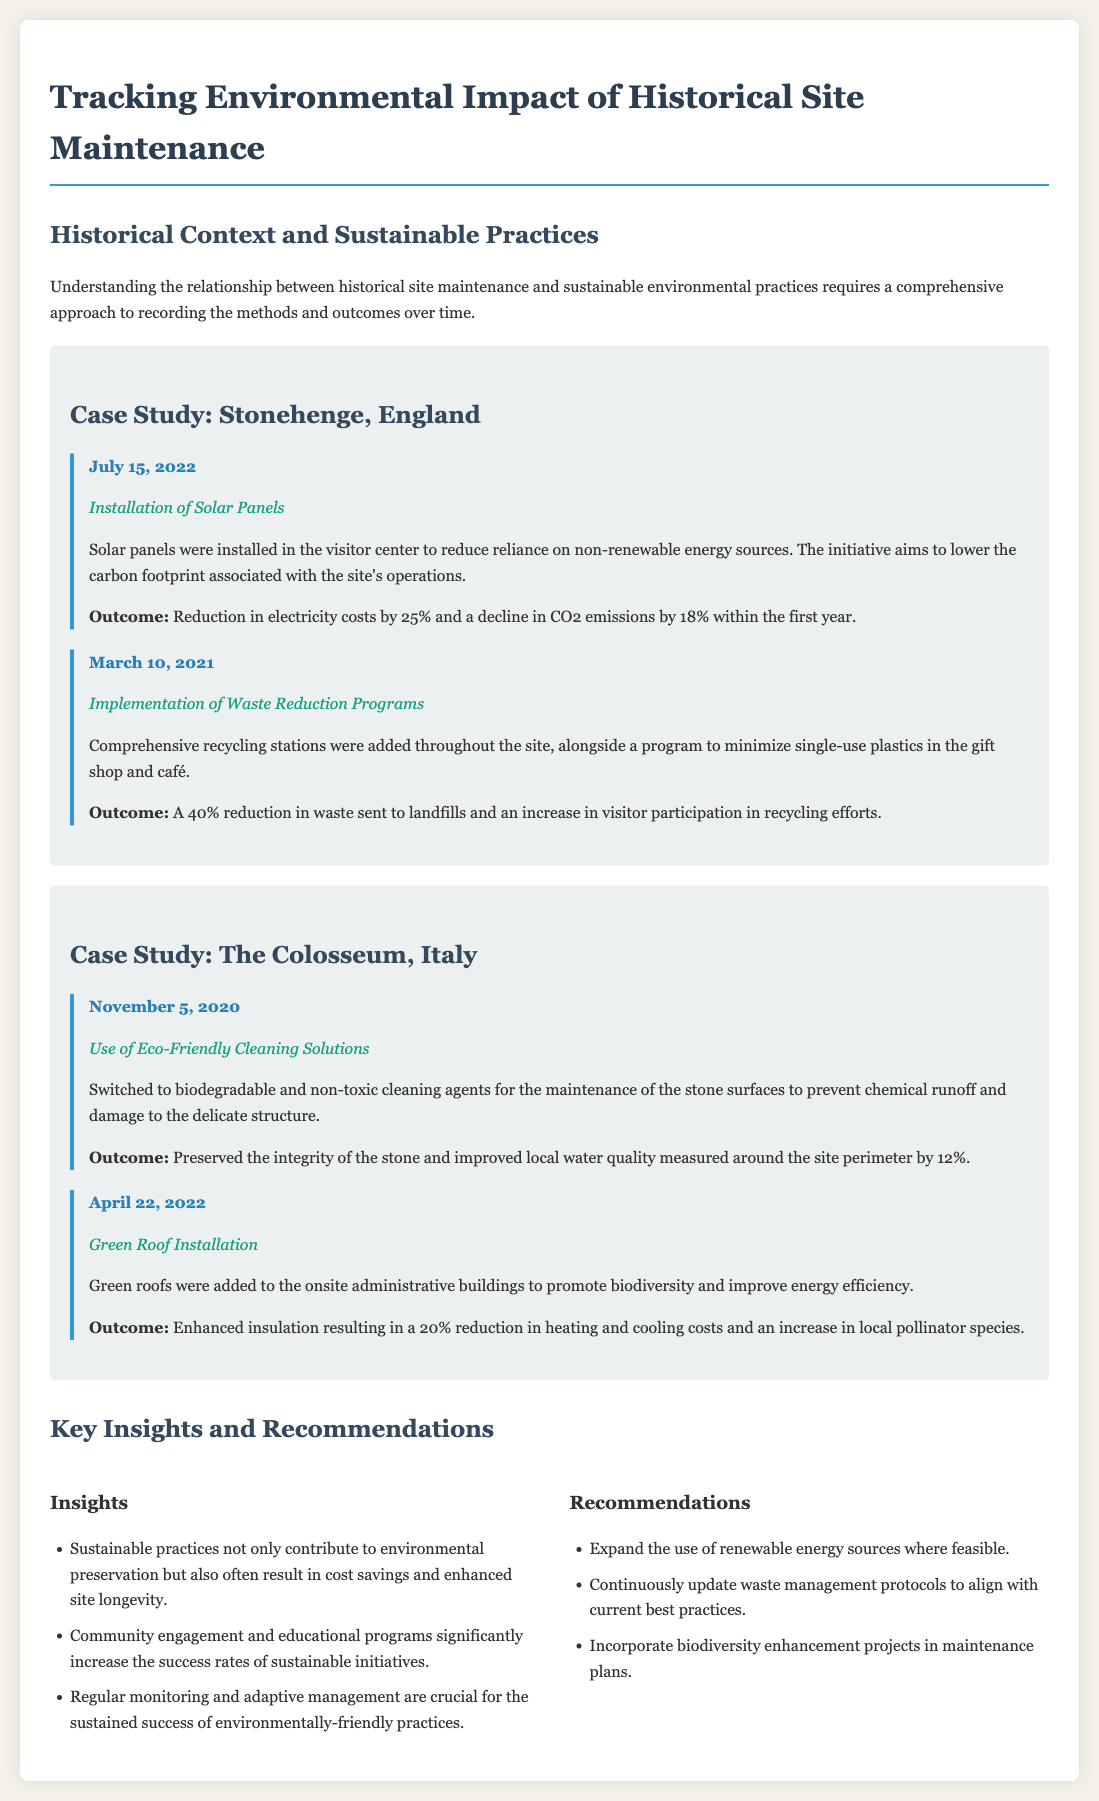What was installed on July 15, 2022? The entry on that date mentions the installation of solar panels in the visitor center at Stonehenge.
Answer: Solar panels What was the outcome of the waste reduction program implemented on March 10, 2021? The document states that a 40% reduction in waste sent to landfills occurred as an outcome of the program.
Answer: 40% When were eco-friendly cleaning solutions switched at The Colosseum? The log indicates that this change occurred on November 5, 2020.
Answer: November 5, 2020 What percentage did CO2 emissions decline by after the solar panels were installed? The document states an 18% decline in CO2 emissions within the first year after installation.
Answer: 18% What recommendation is given regarding waste management? The recommendation suggests to continuously update waste management protocols to align with current best practices.
Answer: Update waste management protocols What specific environmental benefit resulted from installing green roofs? The green roof installation led to an increase in local pollinator species, indicating a biodiversity benefit.
Answer: Increase in local pollinator species What date was the green roof installation recorded? The log entry for the green roof installation at The Colosseum was recorded on April 22, 2022.
Answer: April 22, 2022 What is a key insight regarding community engagement? The document mentions that community engagement significantly increases the success rates of sustainable initiatives.
Answer: Increases success rates What was a 2022 activity related to energy reduction at Stonehenge? The entry reflects the installation of solar panels aimed at energy reduction.
Answer: Installation of Solar Panels 